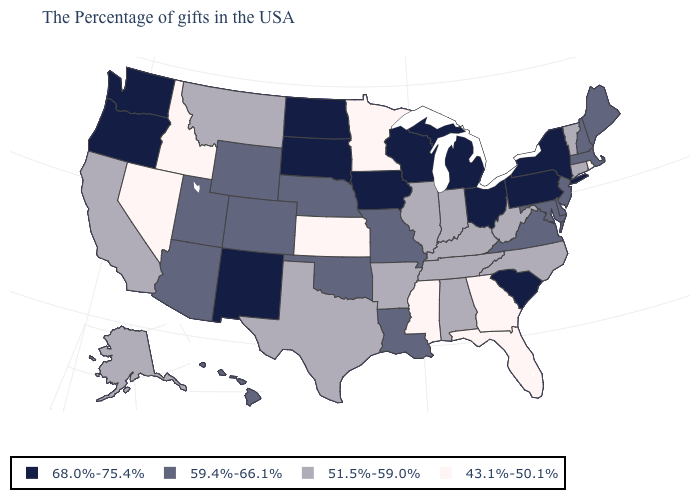Does Florida have the lowest value in the USA?
Be succinct. Yes. Name the states that have a value in the range 43.1%-50.1%?
Keep it brief. Rhode Island, Florida, Georgia, Mississippi, Minnesota, Kansas, Idaho, Nevada. What is the value of South Dakota?
Answer briefly. 68.0%-75.4%. What is the value of Missouri?
Concise answer only. 59.4%-66.1%. Which states have the lowest value in the MidWest?
Answer briefly. Minnesota, Kansas. What is the value of New Mexico?
Be succinct. 68.0%-75.4%. Among the states that border Connecticut , does Massachusetts have the highest value?
Be succinct. No. Does California have a lower value than Tennessee?
Give a very brief answer. No. Name the states that have a value in the range 43.1%-50.1%?
Be succinct. Rhode Island, Florida, Georgia, Mississippi, Minnesota, Kansas, Idaho, Nevada. What is the value of Alabama?
Keep it brief. 51.5%-59.0%. Name the states that have a value in the range 59.4%-66.1%?
Keep it brief. Maine, Massachusetts, New Hampshire, New Jersey, Delaware, Maryland, Virginia, Louisiana, Missouri, Nebraska, Oklahoma, Wyoming, Colorado, Utah, Arizona, Hawaii. Name the states that have a value in the range 51.5%-59.0%?
Write a very short answer. Vermont, Connecticut, North Carolina, West Virginia, Kentucky, Indiana, Alabama, Tennessee, Illinois, Arkansas, Texas, Montana, California, Alaska. Does the map have missing data?
Answer briefly. No. What is the value of Delaware?
Keep it brief. 59.4%-66.1%. Among the states that border Tennessee , does Virginia have the highest value?
Short answer required. Yes. 